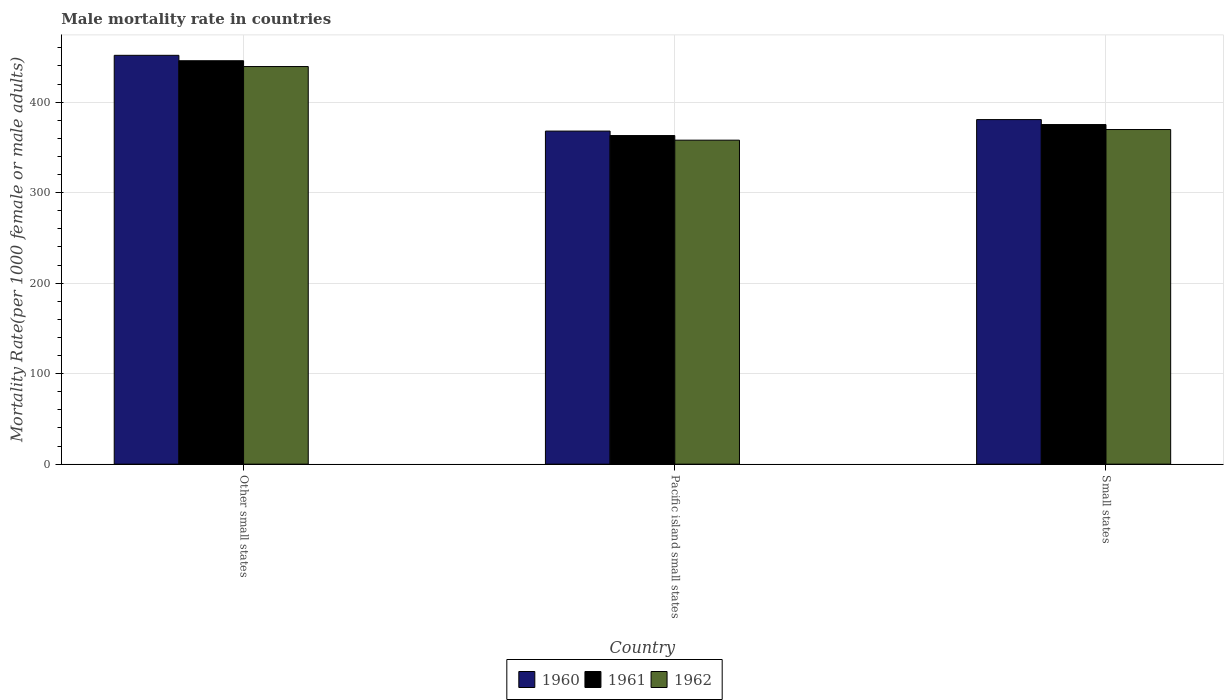How many groups of bars are there?
Your response must be concise. 3. Are the number of bars on each tick of the X-axis equal?
Ensure brevity in your answer.  Yes. What is the label of the 2nd group of bars from the left?
Offer a very short reply. Pacific island small states. What is the male mortality rate in 1960 in Other small states?
Give a very brief answer. 451.71. Across all countries, what is the maximum male mortality rate in 1962?
Your answer should be very brief. 439.31. Across all countries, what is the minimum male mortality rate in 1961?
Offer a very short reply. 363.05. In which country was the male mortality rate in 1962 maximum?
Give a very brief answer. Other small states. In which country was the male mortality rate in 1960 minimum?
Keep it short and to the point. Pacific island small states. What is the total male mortality rate in 1962 in the graph?
Provide a succinct answer. 1166.99. What is the difference between the male mortality rate in 1960 in Other small states and that in Pacific island small states?
Your answer should be compact. 83.71. What is the difference between the male mortality rate in 1961 in Pacific island small states and the male mortality rate in 1962 in Other small states?
Your answer should be compact. -76.26. What is the average male mortality rate in 1962 per country?
Provide a succinct answer. 389. What is the difference between the male mortality rate of/in 1961 and male mortality rate of/in 1960 in Pacific island small states?
Your answer should be compact. -4.95. What is the ratio of the male mortality rate in 1961 in Other small states to that in Small states?
Make the answer very short. 1.19. What is the difference between the highest and the second highest male mortality rate in 1962?
Offer a very short reply. 11.75. What is the difference between the highest and the lowest male mortality rate in 1962?
Your answer should be very brief. 81.34. In how many countries, is the male mortality rate in 1960 greater than the average male mortality rate in 1960 taken over all countries?
Offer a terse response. 1. Is the sum of the male mortality rate in 1960 in Other small states and Pacific island small states greater than the maximum male mortality rate in 1961 across all countries?
Provide a short and direct response. Yes. What does the 2nd bar from the right in Pacific island small states represents?
Keep it short and to the point. 1961. Are all the bars in the graph horizontal?
Your response must be concise. No. How many countries are there in the graph?
Provide a short and direct response. 3. What is the difference between two consecutive major ticks on the Y-axis?
Your answer should be very brief. 100. Does the graph contain any zero values?
Keep it short and to the point. No. Does the graph contain grids?
Your answer should be compact. Yes. Where does the legend appear in the graph?
Give a very brief answer. Bottom center. What is the title of the graph?
Offer a terse response. Male mortality rate in countries. Does "2012" appear as one of the legend labels in the graph?
Your answer should be compact. No. What is the label or title of the X-axis?
Offer a terse response. Country. What is the label or title of the Y-axis?
Provide a succinct answer. Mortality Rate(per 1000 female or male adults). What is the Mortality Rate(per 1000 female or male adults) in 1960 in Other small states?
Offer a very short reply. 451.71. What is the Mortality Rate(per 1000 female or male adults) in 1961 in Other small states?
Provide a short and direct response. 445.72. What is the Mortality Rate(per 1000 female or male adults) in 1962 in Other small states?
Your answer should be very brief. 439.31. What is the Mortality Rate(per 1000 female or male adults) in 1960 in Pacific island small states?
Your answer should be very brief. 368. What is the Mortality Rate(per 1000 female or male adults) of 1961 in Pacific island small states?
Provide a succinct answer. 363.05. What is the Mortality Rate(per 1000 female or male adults) in 1962 in Pacific island small states?
Offer a terse response. 357.97. What is the Mortality Rate(per 1000 female or male adults) of 1960 in Small states?
Ensure brevity in your answer.  380.69. What is the Mortality Rate(per 1000 female or male adults) in 1961 in Small states?
Your answer should be compact. 375.21. What is the Mortality Rate(per 1000 female or male adults) of 1962 in Small states?
Your response must be concise. 369.72. Across all countries, what is the maximum Mortality Rate(per 1000 female or male adults) of 1960?
Make the answer very short. 451.71. Across all countries, what is the maximum Mortality Rate(per 1000 female or male adults) in 1961?
Ensure brevity in your answer.  445.72. Across all countries, what is the maximum Mortality Rate(per 1000 female or male adults) in 1962?
Ensure brevity in your answer.  439.31. Across all countries, what is the minimum Mortality Rate(per 1000 female or male adults) in 1960?
Your response must be concise. 368. Across all countries, what is the minimum Mortality Rate(per 1000 female or male adults) in 1961?
Your answer should be compact. 363.05. Across all countries, what is the minimum Mortality Rate(per 1000 female or male adults) of 1962?
Keep it short and to the point. 357.97. What is the total Mortality Rate(per 1000 female or male adults) in 1960 in the graph?
Your response must be concise. 1200.39. What is the total Mortality Rate(per 1000 female or male adults) in 1961 in the graph?
Ensure brevity in your answer.  1183.98. What is the total Mortality Rate(per 1000 female or male adults) of 1962 in the graph?
Your answer should be very brief. 1166.99. What is the difference between the Mortality Rate(per 1000 female or male adults) in 1960 in Other small states and that in Pacific island small states?
Ensure brevity in your answer.  83.71. What is the difference between the Mortality Rate(per 1000 female or male adults) in 1961 in Other small states and that in Pacific island small states?
Your answer should be very brief. 82.67. What is the difference between the Mortality Rate(per 1000 female or male adults) of 1962 in Other small states and that in Pacific island small states?
Ensure brevity in your answer.  81.34. What is the difference between the Mortality Rate(per 1000 female or male adults) in 1960 in Other small states and that in Small states?
Provide a succinct answer. 71.01. What is the difference between the Mortality Rate(per 1000 female or male adults) of 1961 in Other small states and that in Small states?
Keep it short and to the point. 70.51. What is the difference between the Mortality Rate(per 1000 female or male adults) in 1962 in Other small states and that in Small states?
Provide a short and direct response. 69.6. What is the difference between the Mortality Rate(per 1000 female or male adults) of 1960 in Pacific island small states and that in Small states?
Make the answer very short. -12.69. What is the difference between the Mortality Rate(per 1000 female or male adults) of 1961 in Pacific island small states and that in Small states?
Make the answer very short. -12.16. What is the difference between the Mortality Rate(per 1000 female or male adults) of 1962 in Pacific island small states and that in Small states?
Your answer should be compact. -11.75. What is the difference between the Mortality Rate(per 1000 female or male adults) of 1960 in Other small states and the Mortality Rate(per 1000 female or male adults) of 1961 in Pacific island small states?
Give a very brief answer. 88.65. What is the difference between the Mortality Rate(per 1000 female or male adults) in 1960 in Other small states and the Mortality Rate(per 1000 female or male adults) in 1962 in Pacific island small states?
Provide a short and direct response. 93.74. What is the difference between the Mortality Rate(per 1000 female or male adults) in 1961 in Other small states and the Mortality Rate(per 1000 female or male adults) in 1962 in Pacific island small states?
Offer a terse response. 87.75. What is the difference between the Mortality Rate(per 1000 female or male adults) of 1960 in Other small states and the Mortality Rate(per 1000 female or male adults) of 1961 in Small states?
Your answer should be compact. 76.5. What is the difference between the Mortality Rate(per 1000 female or male adults) of 1960 in Other small states and the Mortality Rate(per 1000 female or male adults) of 1962 in Small states?
Your answer should be compact. 81.99. What is the difference between the Mortality Rate(per 1000 female or male adults) of 1961 in Other small states and the Mortality Rate(per 1000 female or male adults) of 1962 in Small states?
Make the answer very short. 76. What is the difference between the Mortality Rate(per 1000 female or male adults) of 1960 in Pacific island small states and the Mortality Rate(per 1000 female or male adults) of 1961 in Small states?
Give a very brief answer. -7.21. What is the difference between the Mortality Rate(per 1000 female or male adults) in 1960 in Pacific island small states and the Mortality Rate(per 1000 female or male adults) in 1962 in Small states?
Provide a short and direct response. -1.72. What is the difference between the Mortality Rate(per 1000 female or male adults) in 1961 in Pacific island small states and the Mortality Rate(per 1000 female or male adults) in 1962 in Small states?
Keep it short and to the point. -6.66. What is the average Mortality Rate(per 1000 female or male adults) of 1960 per country?
Ensure brevity in your answer.  400.13. What is the average Mortality Rate(per 1000 female or male adults) in 1961 per country?
Offer a very short reply. 394.66. What is the average Mortality Rate(per 1000 female or male adults) in 1962 per country?
Your answer should be compact. 389. What is the difference between the Mortality Rate(per 1000 female or male adults) in 1960 and Mortality Rate(per 1000 female or male adults) in 1961 in Other small states?
Your answer should be very brief. 5.99. What is the difference between the Mortality Rate(per 1000 female or male adults) of 1960 and Mortality Rate(per 1000 female or male adults) of 1962 in Other small states?
Keep it short and to the point. 12.39. What is the difference between the Mortality Rate(per 1000 female or male adults) of 1961 and Mortality Rate(per 1000 female or male adults) of 1962 in Other small states?
Keep it short and to the point. 6.41. What is the difference between the Mortality Rate(per 1000 female or male adults) of 1960 and Mortality Rate(per 1000 female or male adults) of 1961 in Pacific island small states?
Your answer should be very brief. 4.95. What is the difference between the Mortality Rate(per 1000 female or male adults) of 1960 and Mortality Rate(per 1000 female or male adults) of 1962 in Pacific island small states?
Offer a terse response. 10.03. What is the difference between the Mortality Rate(per 1000 female or male adults) of 1961 and Mortality Rate(per 1000 female or male adults) of 1962 in Pacific island small states?
Your answer should be very brief. 5.08. What is the difference between the Mortality Rate(per 1000 female or male adults) of 1960 and Mortality Rate(per 1000 female or male adults) of 1961 in Small states?
Offer a terse response. 5.48. What is the difference between the Mortality Rate(per 1000 female or male adults) of 1960 and Mortality Rate(per 1000 female or male adults) of 1962 in Small states?
Keep it short and to the point. 10.98. What is the difference between the Mortality Rate(per 1000 female or male adults) in 1961 and Mortality Rate(per 1000 female or male adults) in 1962 in Small states?
Offer a terse response. 5.49. What is the ratio of the Mortality Rate(per 1000 female or male adults) of 1960 in Other small states to that in Pacific island small states?
Offer a very short reply. 1.23. What is the ratio of the Mortality Rate(per 1000 female or male adults) in 1961 in Other small states to that in Pacific island small states?
Offer a very short reply. 1.23. What is the ratio of the Mortality Rate(per 1000 female or male adults) of 1962 in Other small states to that in Pacific island small states?
Make the answer very short. 1.23. What is the ratio of the Mortality Rate(per 1000 female or male adults) of 1960 in Other small states to that in Small states?
Your answer should be very brief. 1.19. What is the ratio of the Mortality Rate(per 1000 female or male adults) of 1961 in Other small states to that in Small states?
Offer a very short reply. 1.19. What is the ratio of the Mortality Rate(per 1000 female or male adults) in 1962 in Other small states to that in Small states?
Your answer should be very brief. 1.19. What is the ratio of the Mortality Rate(per 1000 female or male adults) of 1960 in Pacific island small states to that in Small states?
Provide a short and direct response. 0.97. What is the ratio of the Mortality Rate(per 1000 female or male adults) in 1961 in Pacific island small states to that in Small states?
Keep it short and to the point. 0.97. What is the ratio of the Mortality Rate(per 1000 female or male adults) in 1962 in Pacific island small states to that in Small states?
Your answer should be very brief. 0.97. What is the difference between the highest and the second highest Mortality Rate(per 1000 female or male adults) in 1960?
Provide a short and direct response. 71.01. What is the difference between the highest and the second highest Mortality Rate(per 1000 female or male adults) in 1961?
Offer a very short reply. 70.51. What is the difference between the highest and the second highest Mortality Rate(per 1000 female or male adults) in 1962?
Give a very brief answer. 69.6. What is the difference between the highest and the lowest Mortality Rate(per 1000 female or male adults) in 1960?
Provide a succinct answer. 83.71. What is the difference between the highest and the lowest Mortality Rate(per 1000 female or male adults) of 1961?
Offer a terse response. 82.67. What is the difference between the highest and the lowest Mortality Rate(per 1000 female or male adults) in 1962?
Your answer should be compact. 81.34. 